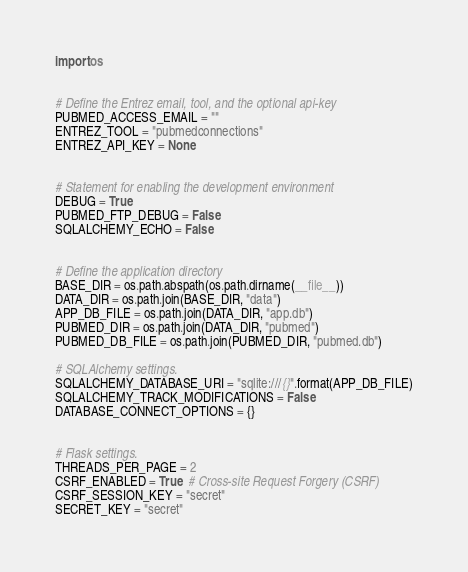<code> <loc_0><loc_0><loc_500><loc_500><_Python_>import os


# Define the Entrez email, tool, and the optional api-key
PUBMED_ACCESS_EMAIL = ""
ENTREZ_TOOL = "pubmedconnections"
ENTREZ_API_KEY = None


# Statement for enabling the development environment
DEBUG = True
PUBMED_FTP_DEBUG = False
SQLALCHEMY_ECHO = False


# Define the application directory
BASE_DIR = os.path.abspath(os.path.dirname(__file__))
DATA_DIR = os.path.join(BASE_DIR, "data")
APP_DB_FILE = os.path.join(DATA_DIR, "app.db")
PUBMED_DIR = os.path.join(DATA_DIR, "pubmed")
PUBMED_DB_FILE = os.path.join(PUBMED_DIR, "pubmed.db")

# SQLAlchemy settings.
SQLALCHEMY_DATABASE_URI = "sqlite:///{}".format(APP_DB_FILE)
SQLALCHEMY_TRACK_MODIFICATIONS = False
DATABASE_CONNECT_OPTIONS = {}


# Flask settings.
THREADS_PER_PAGE = 2
CSRF_ENABLED = True  # Cross-site Request Forgery (CSRF)
CSRF_SESSION_KEY = "secret"
SECRET_KEY = "secret"
</code> 